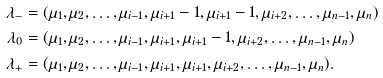<formula> <loc_0><loc_0><loc_500><loc_500>\lambda _ { - } & = ( \mu _ { 1 } , \mu _ { 2 } , \dots , \mu _ { i - 1 } , \mu _ { i + 1 } - 1 , \mu _ { i + 1 } - 1 , \mu _ { i + 2 } , \dots , \mu _ { n - 1 } , \mu _ { n } ) \\ \lambda _ { 0 } & = ( \mu _ { 1 } , \mu _ { 2 } , \dots , \mu _ { i - 1 } , \mu _ { i + 1 } , \mu _ { i + 1 } - 1 , \mu _ { i + 2 } , \dots , \mu _ { n - 1 } , \mu _ { n } ) \\ \lambda _ { + } & = ( \mu _ { 1 } , \mu _ { 2 } , \dots , \mu _ { i - 1 } , \mu _ { i + 1 } , \mu _ { i + 1 } , \mu _ { i + 2 } , \dots , \mu _ { n - 1 } , \mu _ { n } ) .</formula> 